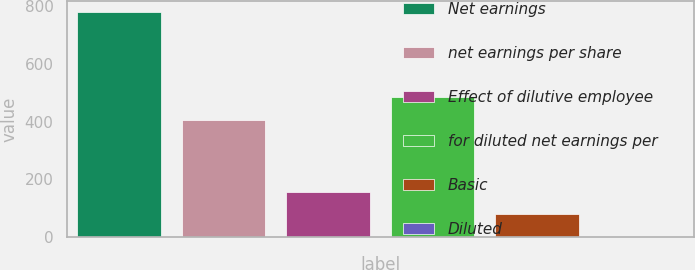Convert chart to OTSL. <chart><loc_0><loc_0><loc_500><loc_500><bar_chart><fcel>Net earnings<fcel>net earnings per share<fcel>Effect of dilutive employee<fcel>for diluted net earnings per<fcel>Basic<fcel>Diluted<nl><fcel>777.7<fcel>406.5<fcel>157.05<fcel>484.08<fcel>79.47<fcel>1.89<nl></chart> 